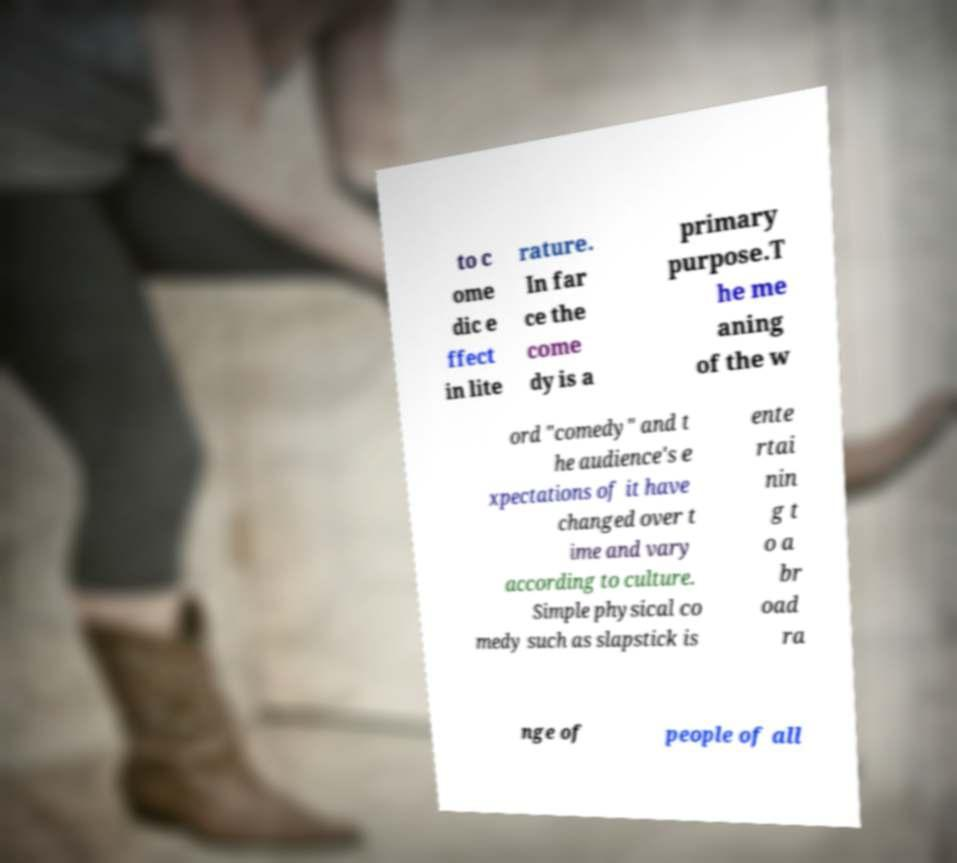Can you read and provide the text displayed in the image?This photo seems to have some interesting text. Can you extract and type it out for me? to c ome dic e ffect in lite rature. In far ce the come dy is a primary purpose.T he me aning of the w ord "comedy" and t he audience's e xpectations of it have changed over t ime and vary according to culture. Simple physical co medy such as slapstick is ente rtai nin g t o a br oad ra nge of people of all 